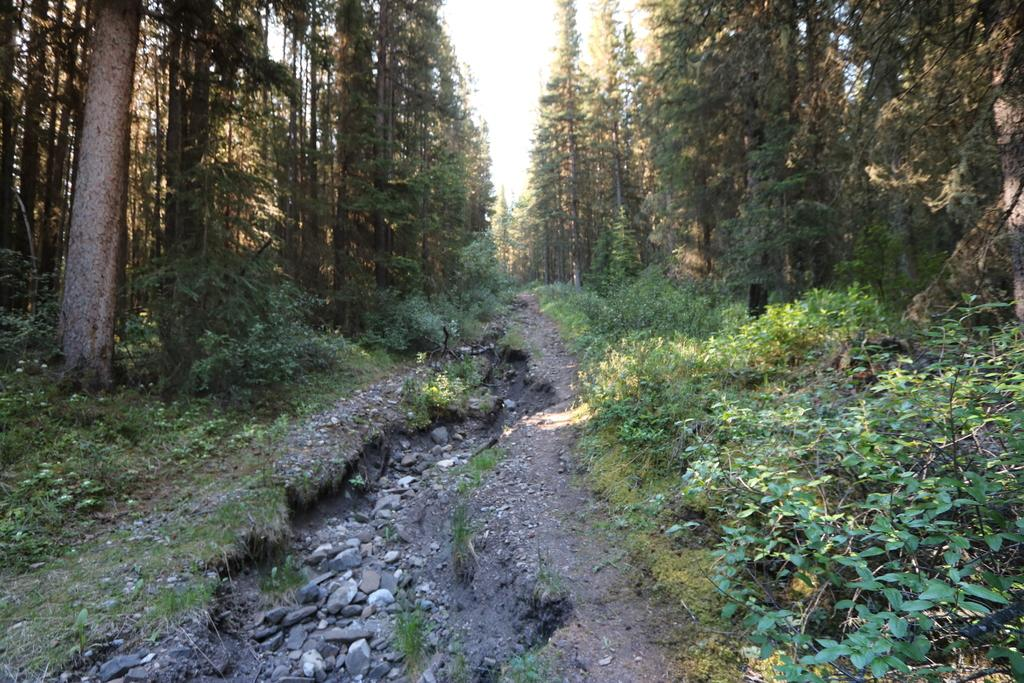What type of environment is shown in the image? The image depicts a forest. What are the main features of the forest? There are trees, grass, and stones visible in the image. What can be seen at the top of the image? The sky is visible at the top of the image. What is visible at the bottom of the image? The ground is visible at the bottom of the image. Can you tell me how many firemen are present in the image? There are no firemen present in the image; it depicts a forest with trees, grass, and stones. What type of straw is used to decorate the trees in the image? There is no straw present in the image; it only features natural elements like trees, grass, and stones. 